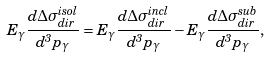Convert formula to latex. <formula><loc_0><loc_0><loc_500><loc_500>E _ { \gamma } \frac { d \Delta \sigma ^ { i s o l } _ { d i r } } { d ^ { 3 } p _ { \gamma } } = E _ { \gamma } \frac { d \Delta \sigma ^ { i n c l } _ { d i r } } { d ^ { 3 } p _ { \gamma } } - E _ { \gamma } \frac { d \Delta \sigma ^ { s u b } _ { d i r } } { d ^ { 3 } p _ { \gamma } } ,</formula> 